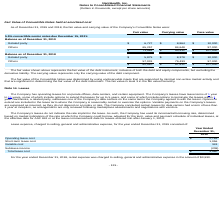According to Nanthealth's financial document, What is the fair value of related party 5.5% convertible senior notes due December 15, 2021 as of December 31, 2019? According to the financial document, $6,727 (in thousands). The relevant text states: "Related party $ 6,727 $ 8,864 $ 10,000..." Also, What is the carrying value of related party 5.5% convertible senior notes due December 15, 2021 as of December 31, 2019? According to the financial document, $8,864 (in thousands). The relevant text states: "Related party $ 6,727 $ 8,864 $ 10,000..." Also, What is the face value of related party 5.5% convertible senior notes due December 15, 2021 as of December 31, 2019? According to the financial document, $10,000 (in thousands). The relevant text states: "Related party $ 6,727 $ 8,864 $ 10,000..." Also, can you calculate: What is the average fair value of related party and other 5.5% convertible senior notes due December 15, 2021 in 2019? To answer this question, I need to perform calculations using the financial data. The calculation is: (6,727 + 65,257)/2 , which equals 35992 (in thousands). This is based on the information: "Related party $ 6,727 $ 8,864 $ 10,000 Others 65,257 84,648 97,000..." The key data points involved are: 6,727, 65,257. Also, can you calculate: What is the percentage change in the fair value of related party 5.5% convertible senior notes due December 15, 2021 between 2018 and 2019? To answer this question, I need to perform calculations using the financial data. The calculation is: (6,727 - 5,879)/5,879 , which equals 14.42 (percentage). This is based on the information: "Related party $ 6,727 $ 8,864 $ 10,000 Related party $ 5,879 $ 8,378 $ 10,000..." The key data points involved are: 5,879, 6,727. Also, can you calculate: What is the total fair value of related party 5.5% convertible senior notes due December 15, 2021 in 2018 and 2019? Based on the calculation: 6,727 + 5,879 , the result is 12606 (in thousands). This is based on the information: "Related party $ 6,727 $ 8,864 $ 10,000 Related party $ 5,879 $ 8,378 $ 10,000..." The key data points involved are: 5,879, 6,727. 